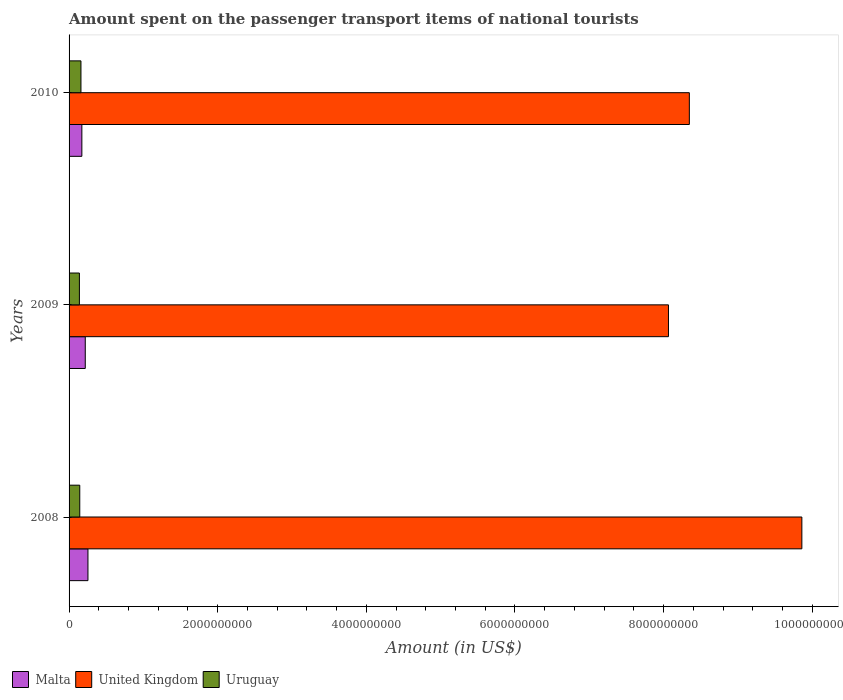How many different coloured bars are there?
Offer a very short reply. 3. Are the number of bars per tick equal to the number of legend labels?
Your answer should be compact. Yes. How many bars are there on the 3rd tick from the top?
Make the answer very short. 3. How many bars are there on the 1st tick from the bottom?
Offer a very short reply. 3. What is the amount spent on the passenger transport items of national tourists in Malta in 2008?
Make the answer very short. 2.54e+08. Across all years, what is the maximum amount spent on the passenger transport items of national tourists in Malta?
Ensure brevity in your answer.  2.54e+08. Across all years, what is the minimum amount spent on the passenger transport items of national tourists in Uruguay?
Offer a very short reply. 1.39e+08. What is the total amount spent on the passenger transport items of national tourists in United Kingdom in the graph?
Offer a very short reply. 2.63e+1. What is the difference between the amount spent on the passenger transport items of national tourists in Malta in 2009 and that in 2010?
Your answer should be very brief. 4.60e+07. What is the difference between the amount spent on the passenger transport items of national tourists in Uruguay in 2010 and the amount spent on the passenger transport items of national tourists in Malta in 2008?
Offer a terse response. -9.40e+07. What is the average amount spent on the passenger transport items of national tourists in Uruguay per year?
Give a very brief answer. 1.48e+08. In how many years, is the amount spent on the passenger transport items of national tourists in Uruguay greater than 7200000000 US$?
Make the answer very short. 0. What is the ratio of the amount spent on the passenger transport items of national tourists in United Kingdom in 2009 to that in 2010?
Offer a very short reply. 0.97. Is the amount spent on the passenger transport items of national tourists in Uruguay in 2008 less than that in 2009?
Give a very brief answer. No. What is the difference between the highest and the second highest amount spent on the passenger transport items of national tourists in Uruguay?
Your response must be concise. 1.60e+07. What is the difference between the highest and the lowest amount spent on the passenger transport items of national tourists in Malta?
Ensure brevity in your answer.  8.20e+07. Is the sum of the amount spent on the passenger transport items of national tourists in Malta in 2008 and 2009 greater than the maximum amount spent on the passenger transport items of national tourists in United Kingdom across all years?
Your answer should be compact. No. What does the 1st bar from the top in 2009 represents?
Make the answer very short. Uruguay. What does the 1st bar from the bottom in 2009 represents?
Your response must be concise. Malta. Is it the case that in every year, the sum of the amount spent on the passenger transport items of national tourists in Uruguay and amount spent on the passenger transport items of national tourists in United Kingdom is greater than the amount spent on the passenger transport items of national tourists in Malta?
Your response must be concise. Yes. How many bars are there?
Provide a short and direct response. 9. Are all the bars in the graph horizontal?
Ensure brevity in your answer.  Yes. How many years are there in the graph?
Keep it short and to the point. 3. What is the difference between two consecutive major ticks on the X-axis?
Your answer should be compact. 2.00e+09. Does the graph contain grids?
Your answer should be compact. No. Where does the legend appear in the graph?
Offer a very short reply. Bottom left. How many legend labels are there?
Keep it short and to the point. 3. What is the title of the graph?
Your answer should be very brief. Amount spent on the passenger transport items of national tourists. What is the label or title of the X-axis?
Your answer should be compact. Amount (in US$). What is the Amount (in US$) in Malta in 2008?
Offer a very short reply. 2.54e+08. What is the Amount (in US$) of United Kingdom in 2008?
Your answer should be compact. 9.86e+09. What is the Amount (in US$) in Uruguay in 2008?
Give a very brief answer. 1.44e+08. What is the Amount (in US$) in Malta in 2009?
Make the answer very short. 2.18e+08. What is the Amount (in US$) in United Kingdom in 2009?
Keep it short and to the point. 8.07e+09. What is the Amount (in US$) in Uruguay in 2009?
Provide a short and direct response. 1.39e+08. What is the Amount (in US$) in Malta in 2010?
Give a very brief answer. 1.72e+08. What is the Amount (in US$) of United Kingdom in 2010?
Provide a short and direct response. 8.35e+09. What is the Amount (in US$) of Uruguay in 2010?
Your answer should be very brief. 1.60e+08. Across all years, what is the maximum Amount (in US$) of Malta?
Your response must be concise. 2.54e+08. Across all years, what is the maximum Amount (in US$) in United Kingdom?
Your response must be concise. 9.86e+09. Across all years, what is the maximum Amount (in US$) in Uruguay?
Provide a succinct answer. 1.60e+08. Across all years, what is the minimum Amount (in US$) in Malta?
Your answer should be compact. 1.72e+08. Across all years, what is the minimum Amount (in US$) in United Kingdom?
Make the answer very short. 8.07e+09. Across all years, what is the minimum Amount (in US$) in Uruguay?
Your response must be concise. 1.39e+08. What is the total Amount (in US$) in Malta in the graph?
Keep it short and to the point. 6.44e+08. What is the total Amount (in US$) in United Kingdom in the graph?
Provide a short and direct response. 2.63e+1. What is the total Amount (in US$) in Uruguay in the graph?
Provide a short and direct response. 4.43e+08. What is the difference between the Amount (in US$) of Malta in 2008 and that in 2009?
Provide a succinct answer. 3.60e+07. What is the difference between the Amount (in US$) of United Kingdom in 2008 and that in 2009?
Ensure brevity in your answer.  1.80e+09. What is the difference between the Amount (in US$) of Malta in 2008 and that in 2010?
Ensure brevity in your answer.  8.20e+07. What is the difference between the Amount (in US$) in United Kingdom in 2008 and that in 2010?
Keep it short and to the point. 1.51e+09. What is the difference between the Amount (in US$) of Uruguay in 2008 and that in 2010?
Offer a very short reply. -1.60e+07. What is the difference between the Amount (in US$) in Malta in 2009 and that in 2010?
Offer a terse response. 4.60e+07. What is the difference between the Amount (in US$) of United Kingdom in 2009 and that in 2010?
Ensure brevity in your answer.  -2.81e+08. What is the difference between the Amount (in US$) in Uruguay in 2009 and that in 2010?
Make the answer very short. -2.10e+07. What is the difference between the Amount (in US$) of Malta in 2008 and the Amount (in US$) of United Kingdom in 2009?
Ensure brevity in your answer.  -7.81e+09. What is the difference between the Amount (in US$) in Malta in 2008 and the Amount (in US$) in Uruguay in 2009?
Your response must be concise. 1.15e+08. What is the difference between the Amount (in US$) in United Kingdom in 2008 and the Amount (in US$) in Uruguay in 2009?
Ensure brevity in your answer.  9.72e+09. What is the difference between the Amount (in US$) of Malta in 2008 and the Amount (in US$) of United Kingdom in 2010?
Ensure brevity in your answer.  -8.09e+09. What is the difference between the Amount (in US$) in Malta in 2008 and the Amount (in US$) in Uruguay in 2010?
Keep it short and to the point. 9.40e+07. What is the difference between the Amount (in US$) of United Kingdom in 2008 and the Amount (in US$) of Uruguay in 2010?
Ensure brevity in your answer.  9.70e+09. What is the difference between the Amount (in US$) in Malta in 2009 and the Amount (in US$) in United Kingdom in 2010?
Your response must be concise. -8.13e+09. What is the difference between the Amount (in US$) of Malta in 2009 and the Amount (in US$) of Uruguay in 2010?
Your answer should be very brief. 5.80e+07. What is the difference between the Amount (in US$) in United Kingdom in 2009 and the Amount (in US$) in Uruguay in 2010?
Your answer should be very brief. 7.91e+09. What is the average Amount (in US$) in Malta per year?
Provide a succinct answer. 2.15e+08. What is the average Amount (in US$) of United Kingdom per year?
Give a very brief answer. 8.76e+09. What is the average Amount (in US$) of Uruguay per year?
Provide a succinct answer. 1.48e+08. In the year 2008, what is the difference between the Amount (in US$) of Malta and Amount (in US$) of United Kingdom?
Your answer should be compact. -9.61e+09. In the year 2008, what is the difference between the Amount (in US$) in Malta and Amount (in US$) in Uruguay?
Your response must be concise. 1.10e+08. In the year 2008, what is the difference between the Amount (in US$) of United Kingdom and Amount (in US$) of Uruguay?
Keep it short and to the point. 9.72e+09. In the year 2009, what is the difference between the Amount (in US$) in Malta and Amount (in US$) in United Kingdom?
Give a very brief answer. -7.85e+09. In the year 2009, what is the difference between the Amount (in US$) in Malta and Amount (in US$) in Uruguay?
Your answer should be very brief. 7.90e+07. In the year 2009, what is the difference between the Amount (in US$) in United Kingdom and Amount (in US$) in Uruguay?
Ensure brevity in your answer.  7.93e+09. In the year 2010, what is the difference between the Amount (in US$) in Malta and Amount (in US$) in United Kingdom?
Ensure brevity in your answer.  -8.18e+09. In the year 2010, what is the difference between the Amount (in US$) of Malta and Amount (in US$) of Uruguay?
Your response must be concise. 1.20e+07. In the year 2010, what is the difference between the Amount (in US$) in United Kingdom and Amount (in US$) in Uruguay?
Provide a short and direct response. 8.19e+09. What is the ratio of the Amount (in US$) of Malta in 2008 to that in 2009?
Keep it short and to the point. 1.17. What is the ratio of the Amount (in US$) of United Kingdom in 2008 to that in 2009?
Give a very brief answer. 1.22. What is the ratio of the Amount (in US$) in Uruguay in 2008 to that in 2009?
Provide a succinct answer. 1.04. What is the ratio of the Amount (in US$) in Malta in 2008 to that in 2010?
Ensure brevity in your answer.  1.48. What is the ratio of the Amount (in US$) in United Kingdom in 2008 to that in 2010?
Provide a succinct answer. 1.18. What is the ratio of the Amount (in US$) in Malta in 2009 to that in 2010?
Make the answer very short. 1.27. What is the ratio of the Amount (in US$) in United Kingdom in 2009 to that in 2010?
Provide a succinct answer. 0.97. What is the ratio of the Amount (in US$) of Uruguay in 2009 to that in 2010?
Offer a terse response. 0.87. What is the difference between the highest and the second highest Amount (in US$) in Malta?
Your response must be concise. 3.60e+07. What is the difference between the highest and the second highest Amount (in US$) of United Kingdom?
Your response must be concise. 1.51e+09. What is the difference between the highest and the second highest Amount (in US$) in Uruguay?
Provide a short and direct response. 1.60e+07. What is the difference between the highest and the lowest Amount (in US$) in Malta?
Your answer should be compact. 8.20e+07. What is the difference between the highest and the lowest Amount (in US$) of United Kingdom?
Keep it short and to the point. 1.80e+09. What is the difference between the highest and the lowest Amount (in US$) of Uruguay?
Your answer should be compact. 2.10e+07. 